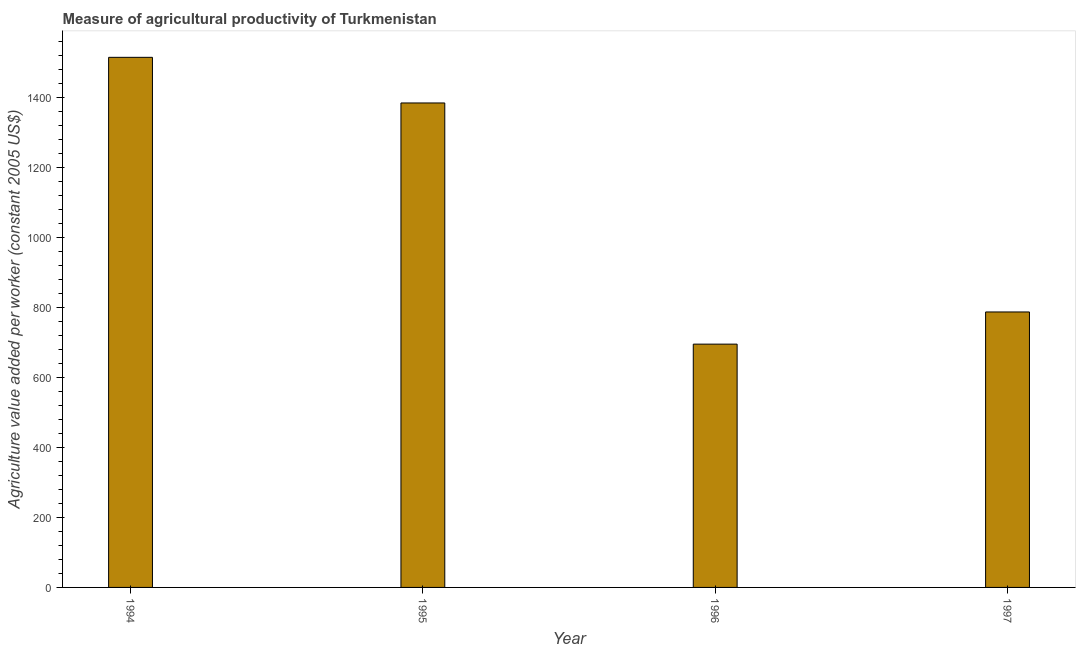What is the title of the graph?
Offer a very short reply. Measure of agricultural productivity of Turkmenistan. What is the label or title of the Y-axis?
Your response must be concise. Agriculture value added per worker (constant 2005 US$). What is the agriculture value added per worker in 1995?
Your response must be concise. 1383.28. Across all years, what is the maximum agriculture value added per worker?
Offer a terse response. 1513.59. Across all years, what is the minimum agriculture value added per worker?
Your response must be concise. 694.66. In which year was the agriculture value added per worker maximum?
Provide a short and direct response. 1994. What is the sum of the agriculture value added per worker?
Your response must be concise. 4378.07. What is the difference between the agriculture value added per worker in 1995 and 1996?
Your answer should be very brief. 688.62. What is the average agriculture value added per worker per year?
Give a very brief answer. 1094.52. What is the median agriculture value added per worker?
Give a very brief answer. 1084.91. In how many years, is the agriculture value added per worker greater than 680 US$?
Your answer should be compact. 4. What is the ratio of the agriculture value added per worker in 1994 to that in 1995?
Offer a very short reply. 1.09. Is the agriculture value added per worker in 1994 less than that in 1995?
Offer a terse response. No. Is the difference between the agriculture value added per worker in 1996 and 1997 greater than the difference between any two years?
Give a very brief answer. No. What is the difference between the highest and the second highest agriculture value added per worker?
Provide a succinct answer. 130.3. Is the sum of the agriculture value added per worker in 1994 and 1997 greater than the maximum agriculture value added per worker across all years?
Keep it short and to the point. Yes. What is the difference between the highest and the lowest agriculture value added per worker?
Provide a short and direct response. 818.93. How many bars are there?
Offer a terse response. 4. Are all the bars in the graph horizontal?
Your answer should be compact. No. Are the values on the major ticks of Y-axis written in scientific E-notation?
Your answer should be compact. No. What is the Agriculture value added per worker (constant 2005 US$) of 1994?
Give a very brief answer. 1513.59. What is the Agriculture value added per worker (constant 2005 US$) of 1995?
Ensure brevity in your answer.  1383.28. What is the Agriculture value added per worker (constant 2005 US$) of 1996?
Offer a very short reply. 694.66. What is the Agriculture value added per worker (constant 2005 US$) in 1997?
Your answer should be very brief. 786.55. What is the difference between the Agriculture value added per worker (constant 2005 US$) in 1994 and 1995?
Make the answer very short. 130.3. What is the difference between the Agriculture value added per worker (constant 2005 US$) in 1994 and 1996?
Keep it short and to the point. 818.93. What is the difference between the Agriculture value added per worker (constant 2005 US$) in 1994 and 1997?
Keep it short and to the point. 727.04. What is the difference between the Agriculture value added per worker (constant 2005 US$) in 1995 and 1996?
Give a very brief answer. 688.62. What is the difference between the Agriculture value added per worker (constant 2005 US$) in 1995 and 1997?
Offer a terse response. 596.73. What is the difference between the Agriculture value added per worker (constant 2005 US$) in 1996 and 1997?
Offer a terse response. -91.89. What is the ratio of the Agriculture value added per worker (constant 2005 US$) in 1994 to that in 1995?
Your answer should be compact. 1.09. What is the ratio of the Agriculture value added per worker (constant 2005 US$) in 1994 to that in 1996?
Provide a short and direct response. 2.18. What is the ratio of the Agriculture value added per worker (constant 2005 US$) in 1994 to that in 1997?
Offer a terse response. 1.92. What is the ratio of the Agriculture value added per worker (constant 2005 US$) in 1995 to that in 1996?
Provide a succinct answer. 1.99. What is the ratio of the Agriculture value added per worker (constant 2005 US$) in 1995 to that in 1997?
Ensure brevity in your answer.  1.76. What is the ratio of the Agriculture value added per worker (constant 2005 US$) in 1996 to that in 1997?
Offer a very short reply. 0.88. 